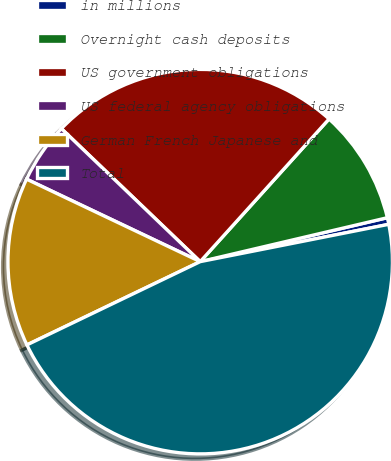Convert chart to OTSL. <chart><loc_0><loc_0><loc_500><loc_500><pie_chart><fcel>in millions<fcel>Overnight cash deposits<fcel>US government obligations<fcel>US federal agency obligations<fcel>German French Japanese and<fcel>Total<nl><fcel>0.56%<fcel>9.64%<fcel>24.53%<fcel>5.1%<fcel>14.19%<fcel>45.98%<nl></chart> 